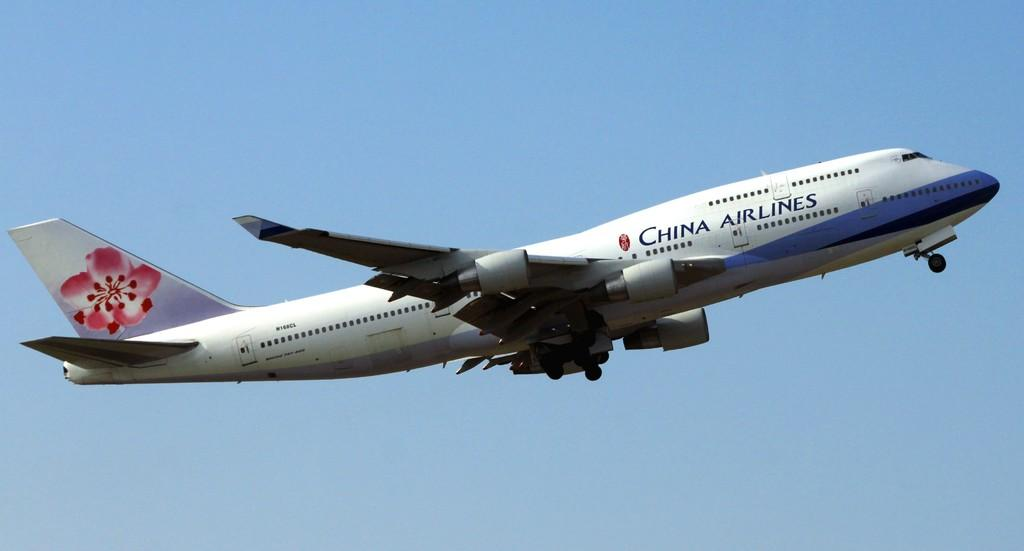<image>
Describe the image concisely. The plane flying in the air is fom China Airlines. 